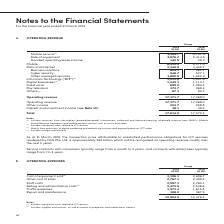According to Singapore Telecommunications's financial document, What is this the topic of this note 5? According to the financial document, Operating Expenses. The relevant text states: "5. OPERATING EXPENSES..." Also, What does cost of equipment sold include? Includes equipment costs related to ICT services.. The document states: "(1) Includes equipment costs related to ICT services...." Also, What does selling and administrative costs include? Includes supplies and services, as well as rentals of properties and mobile base stations.. The document states: "(2) Includes supplies and services, as well as rentals of properties and mobile base stations...." Additionally, In which year did Singtel had higher total operating expenses? According to the financial document, 2019. The relevant text states: "Group 2019 S$ Mil 2018 S$ Mil..." Also, How many different type of operating expenses are there? Counting the relevant items in the document: Cost of equipment sold,  Other cost of sales,  Staff costs,  Selling and administrative costs,  Traffic Expenses,  Repair and maintenance, I find 6 instances. The key data points involved are: Cost of equipment sold, Other cost of sales, Repair and maintenance. Also, can you calculate: What is the average of the top 3 operating expenses subcategories in 2019? To answer this question, I need to perform calculations using the financial data. The calculation is: (3,106.1 + 2,767.1 + 2,597.3) / 3, which equals 2823.5 (in millions). This is based on the information: "ment sold (1) 3,106.1 2,696.7 Other cost of sales 2,767.1 2,499.2 Staff costs 2,597.3 2,760.1 Selling and administrative costs (2) 2,472.6 2,536.6 Traffic ex Cost of equipment sold (1) 3,106.1 2,696.7..." The key data points involved are: 2,597.3, 2,767.1, 3,106.1. 